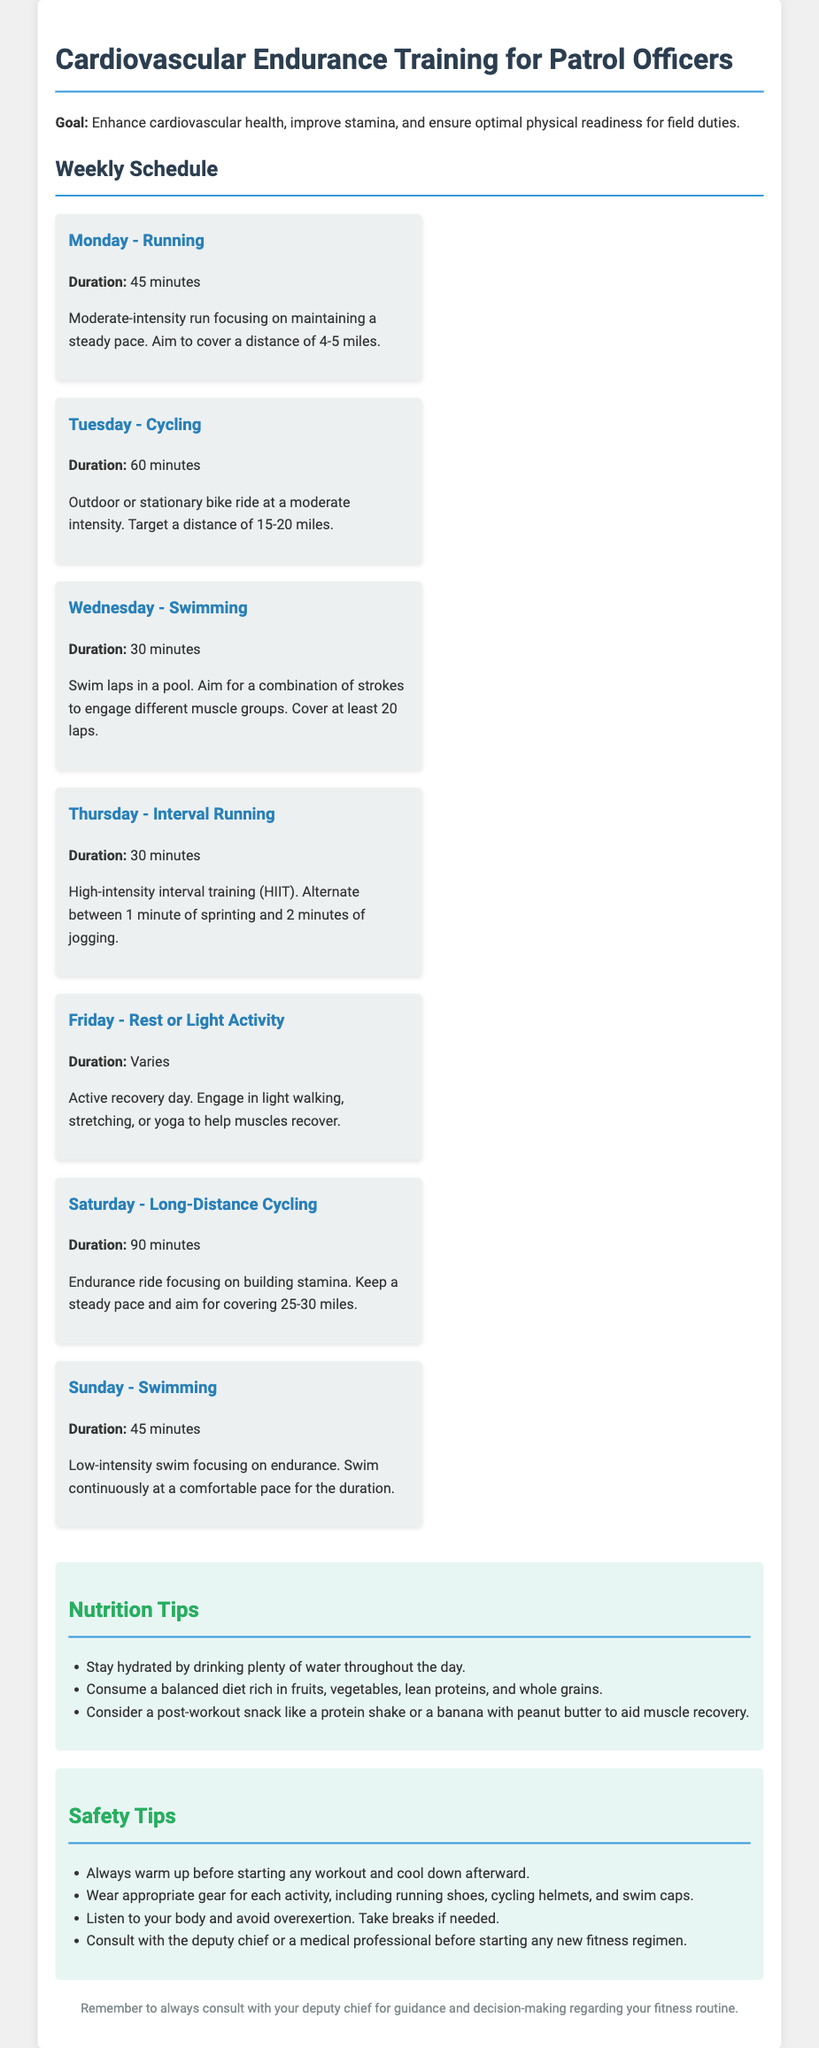What is the goal of the workout plan? The goal of the workout plan is to enhance cardiovascular health, improve stamina, and ensure optimal physical readiness for field duties.
Answer: Enhance cardiovascular health, improve stamina, and ensure optimal physical readiness for field duties What is the duration of the interval running session? The duration for the interval running session is specified in the schedule section of the document as 30 minutes.
Answer: 30 minutes How many miles should be targeted during the Tuesday cycling session? The document specifies a target distance of 15-20 miles for the Tuesday cycling session.
Answer: 15-20 miles On which day is a rest or light activity recommended? The schedule indicates that Friday is designated as a rest or light activity day.
Answer: Friday What type of high-intensity training is mentioned for Thursday? The document describes high-intensity interval training (HIIT) for Thursday's workout.
Answer: High-intensity interval training (HIIT) How long should the Sunday swimming session last? According to the weekly schedule, the Sunday swimming session should last for 45 minutes.
Answer: 45 minutes What is recommended for post-workout nutrition? The document suggests considering a post-workout snack like a protein shake or a banana with peanut butter to aid muscle recovery.
Answer: Protein shake or banana with peanut butter What should be worn for cycling activities? The document states that wearing a cycling helmet is necessary for cycling activities.
Answer: Cycling helmet What type of warm-up does the safety tip mention? The safety tips recommend always warming up before starting any workout.
Answer: Warming up before starting any workout 